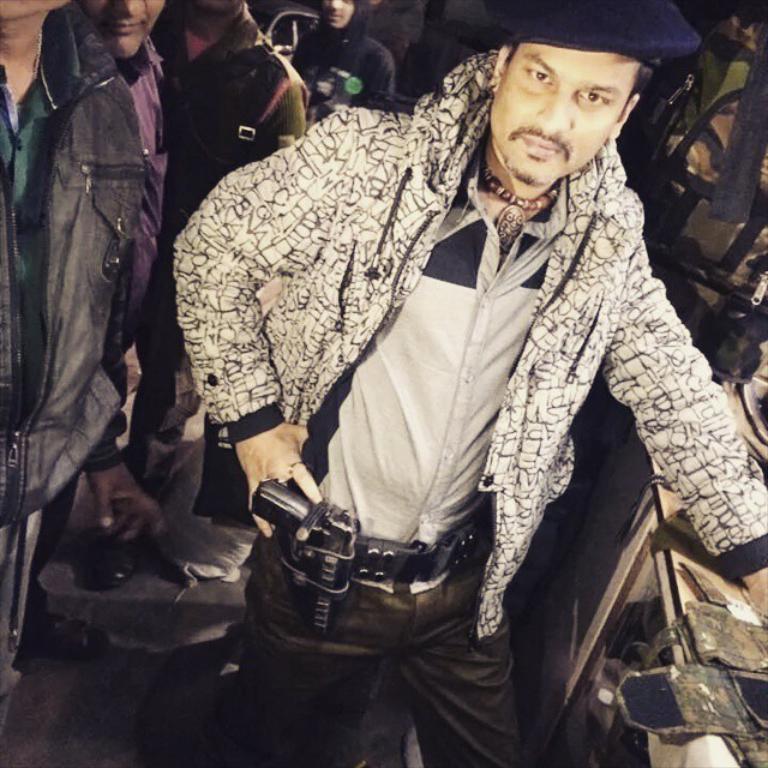In one or two sentences, can you explain what this image depicts? In this picture we can see a man wore a cap, jacket and standing on the floor, gun and at the back of him we can see some people and some objects. 